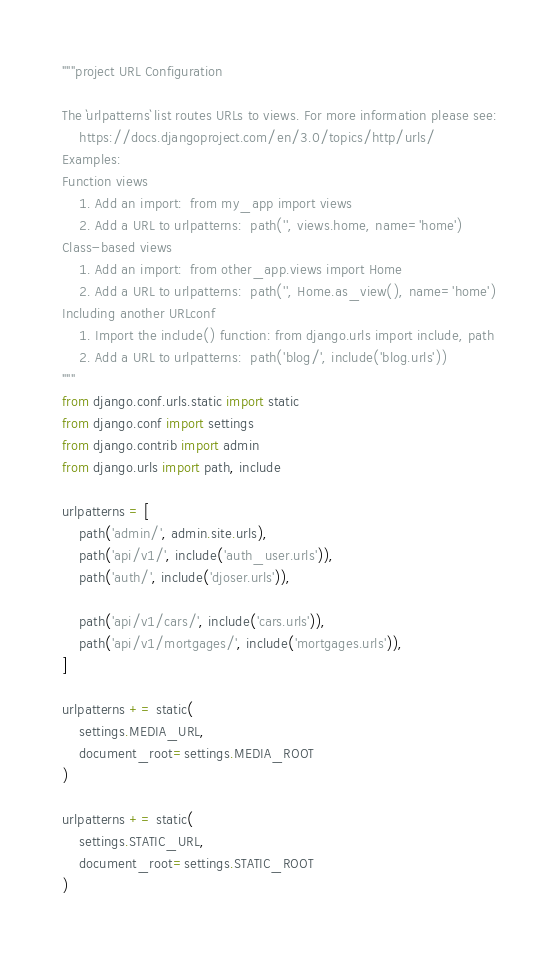Convert code to text. <code><loc_0><loc_0><loc_500><loc_500><_Python_>"""project URL Configuration

The `urlpatterns` list routes URLs to views. For more information please see:
    https://docs.djangoproject.com/en/3.0/topics/http/urls/
Examples:
Function views
    1. Add an import:  from my_app import views
    2. Add a URL to urlpatterns:  path('', views.home, name='home')
Class-based views
    1. Add an import:  from other_app.views import Home
    2. Add a URL to urlpatterns:  path('', Home.as_view(), name='home')
Including another URLconf
    1. Import the include() function: from django.urls import include, path
    2. Add a URL to urlpatterns:  path('blog/', include('blog.urls'))
"""
from django.conf.urls.static import static
from django.conf import settings
from django.contrib import admin
from django.urls import path, include

urlpatterns = [
    path('admin/', admin.site.urls),
    path('api/v1/', include('auth_user.urls')),
    path('auth/', include('djoser.urls')),

    path('api/v1/cars/', include('cars.urls')),
    path('api/v1/mortgages/', include('mortgages.urls')),
]

urlpatterns += static(
    settings.MEDIA_URL,
    document_root=settings.MEDIA_ROOT
)

urlpatterns += static(
    settings.STATIC_URL,
    document_root=settings.STATIC_ROOT
)
</code> 